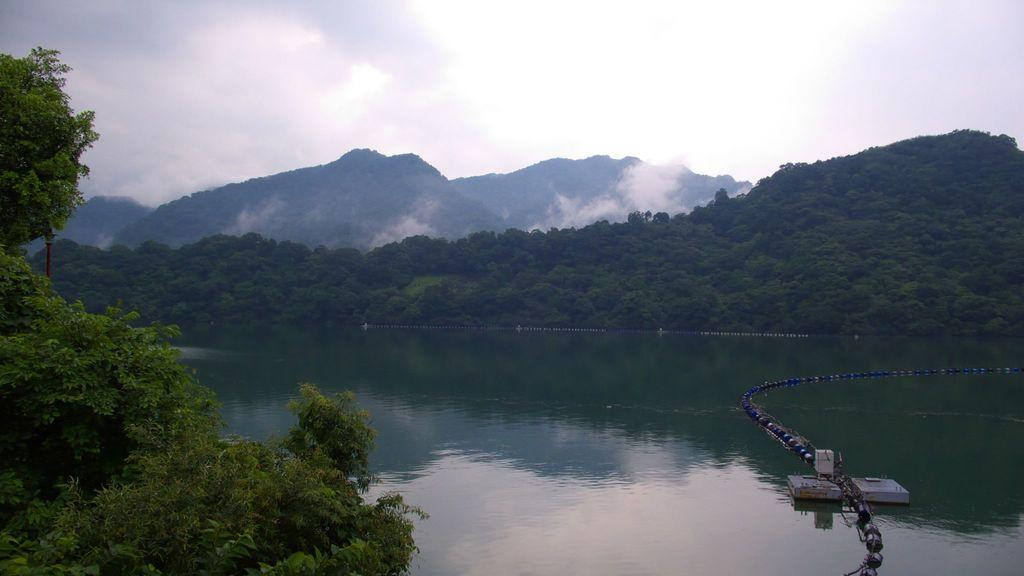What is floating in the water in the image? There are objects floating in the water in the water in the image. What can be seen in the background of the image? Trees, mountains, and fog are visible in the background of the image. How would you describe the sky in the image? The sky is cloudy in the background of the image. What type of company is depicted on the wall in the image? There is no wall or company present in the image; it features objects floating in the water and a background with trees, mountains, fog, and a cloudy sky. Are there any trains visible in the image? There are no trains present in the image. 